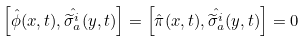Convert formula to latex. <formula><loc_0><loc_0><loc_500><loc_500>\left [ \hat { \phi } ( x , t ) , \hat { \widetilde { \sigma } ^ { i } _ { a } } ( y , t ) \right ] = \left [ \hat { \pi } ( x , t ) , \hat { \widetilde { \sigma } ^ { i } _ { a } } ( y , t ) \right ] = 0</formula> 